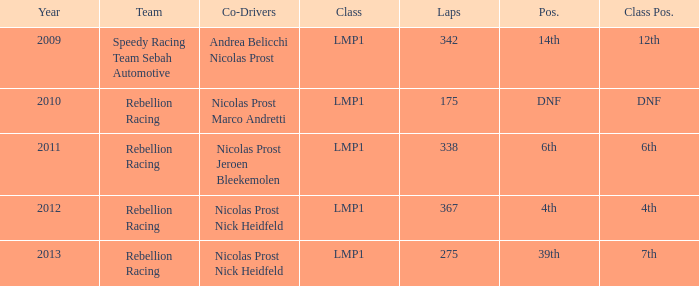What is Class Pos., when Year is before 2013, and when Laps is greater than 175? 12th, 6th, 4th. 